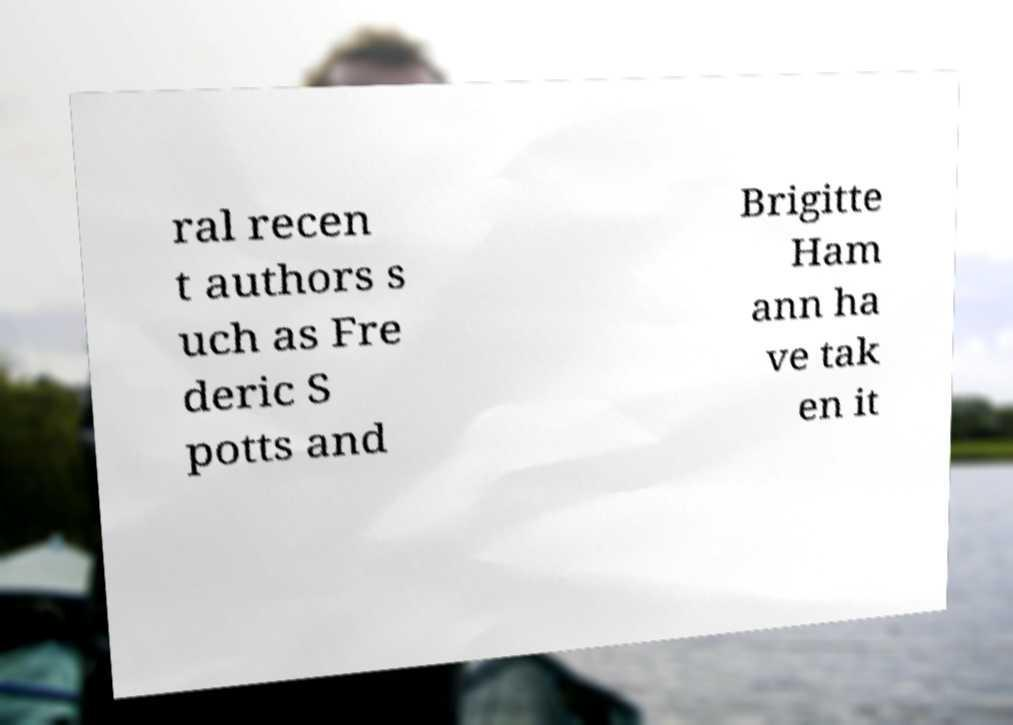Please identify and transcribe the text found in this image. ral recen t authors s uch as Fre deric S potts and Brigitte Ham ann ha ve tak en it 